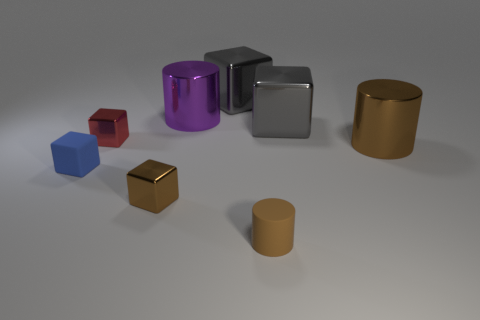Are there fewer tiny matte cylinders that are on the left side of the purple metallic cylinder than large shiny cylinders that are in front of the tiny red object?
Your response must be concise. Yes. Is the tiny brown matte thing the same shape as the red shiny object?
Provide a succinct answer. No. How many other shiny cylinders are the same size as the purple metal cylinder?
Ensure brevity in your answer.  1. Is the number of purple metal things that are on the left side of the small brown metal object less than the number of small green matte balls?
Offer a very short reply. No. There is a metallic cylinder that is right of the cylinder in front of the blue object; what size is it?
Provide a succinct answer. Large. How many things are either shiny things or big things?
Offer a terse response. 6. Are there any shiny cubes of the same color as the small cylinder?
Your response must be concise. Yes. Is the number of large yellow metal objects less than the number of cylinders?
Your answer should be very brief. Yes. What number of things are gray metal objects or metallic objects that are behind the big purple metal object?
Ensure brevity in your answer.  2. Are there any yellow cubes made of the same material as the blue cube?
Provide a succinct answer. No. 